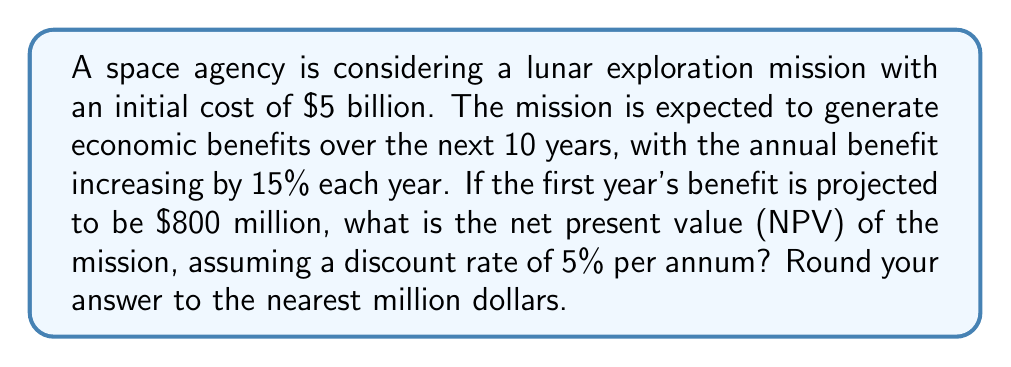Show me your answer to this math problem. To solve this problem, we need to:
1. Calculate the economic benefits for each year
2. Discount these benefits to present value
3. Sum up the present values
4. Subtract the initial cost

Let's go through these steps:

1. Calculate annual benefits:
   Year 1: $800 million
   Year 2: $800 million * 1.15 = $920 million
   Year 3: $920 million * 1.15 = $1,058 million
   And so on...

2. Discount each year's benefit to present value:
   PV = FV / (1 + r)^n, where r is the discount rate and n is the number of years

3. Sum up the present values:
   Let's use a formula for the sum of a geometric series:
   
   $$ S = \frac{a(1-r^n)}{1-r} $$
   
   where a is the first term, r is the common ratio, and n is the number of terms.
   
   In our case:
   a = $800 million
   r = 1.15 / 1.05 = 1.0952 (growth rate divided by discount rate)
   n = 10 years

   $$ S = \frac{800(1-1.0952^{10})}{1-1.0952} = 11,784.62 \text{ million} $$

4. Subtract the initial cost:
   NPV = $11,784.62 million - $5,000 million = $6,784.62 million
Answer: $6,785 million 